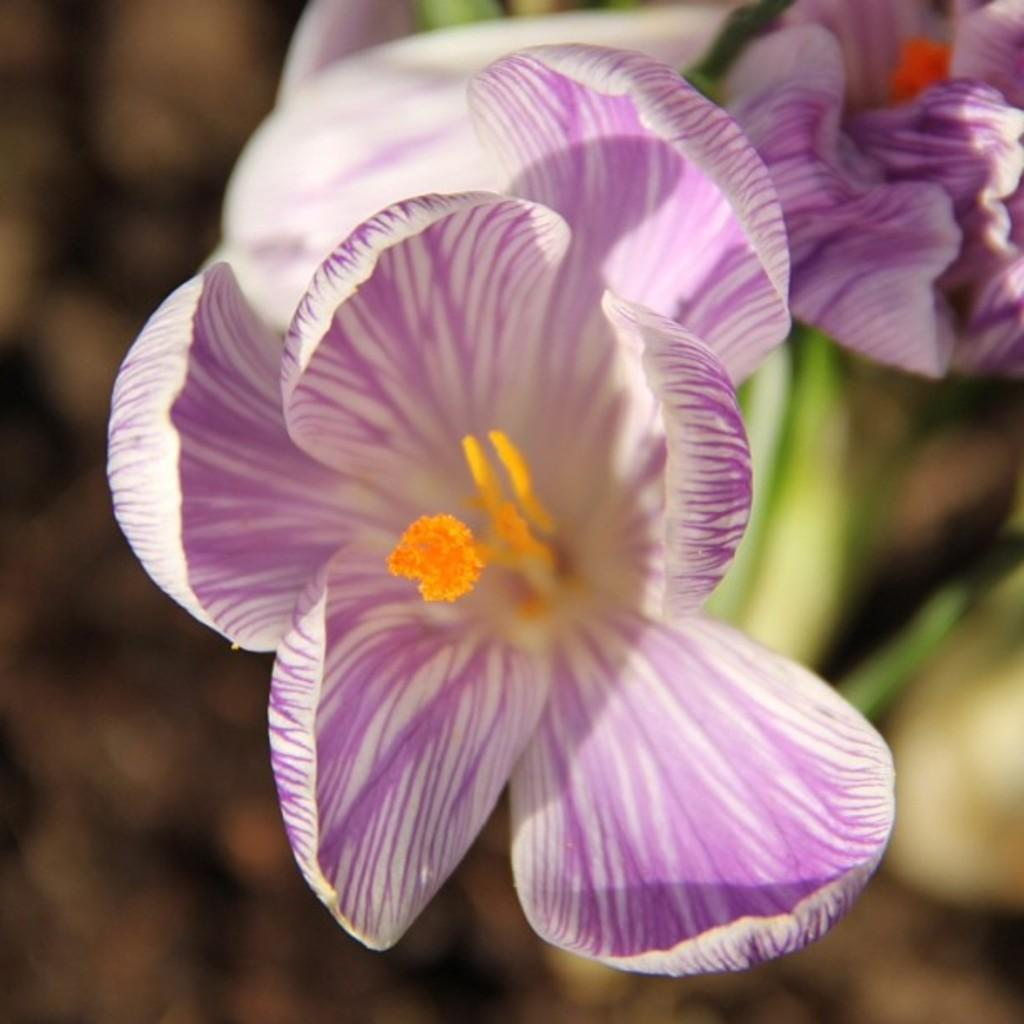Where was the image taken? The image was taken outdoors. What can be seen on the right side of the image? There is a plant with beautiful flowers on the right side of the image. How many clocks are visible in the image? There are no clocks visible in the image. What type of game is being played in the image? There is no game being played in the image. 